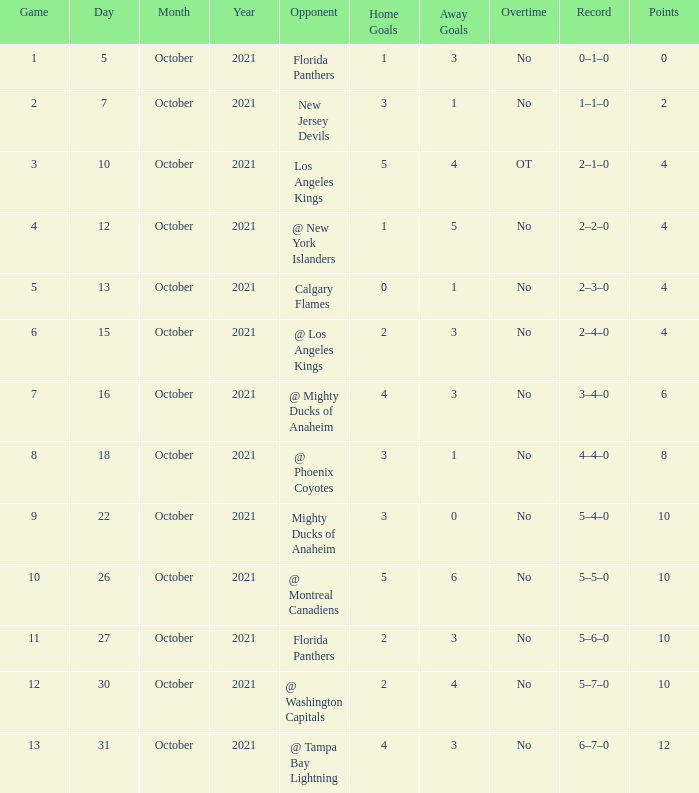What team has a score of 2 3–1. 